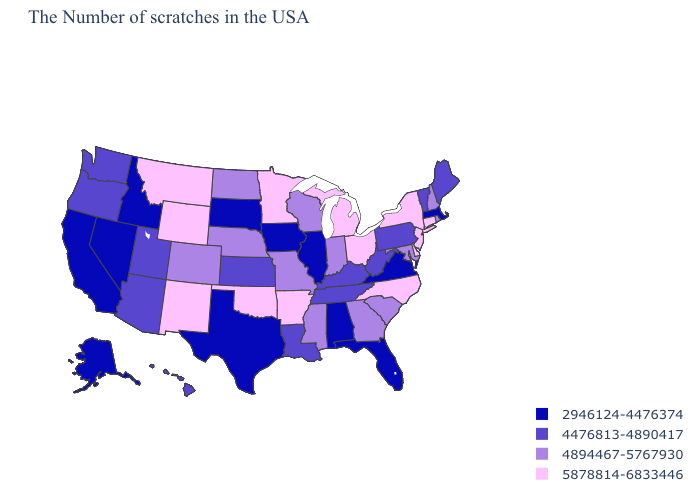Among the states that border Pennsylvania , which have the highest value?
Write a very short answer. New York, New Jersey, Delaware, Ohio. Does Hawaii have the same value as West Virginia?
Answer briefly. Yes. Which states have the lowest value in the USA?
Answer briefly. Massachusetts, Virginia, Florida, Alabama, Illinois, Iowa, Texas, South Dakota, Idaho, Nevada, California, Alaska. Does the map have missing data?
Keep it brief. No. What is the value of Michigan?
Write a very short answer. 5878814-6833446. Does Massachusetts have the highest value in the Northeast?
Answer briefly. No. What is the lowest value in states that border Mississippi?
Short answer required. 2946124-4476374. Does the map have missing data?
Concise answer only. No. Does Florida have the highest value in the USA?
Short answer required. No. Name the states that have a value in the range 5878814-6833446?
Short answer required. Connecticut, New York, New Jersey, Delaware, North Carolina, Ohio, Michigan, Arkansas, Minnesota, Oklahoma, Wyoming, New Mexico, Montana. What is the lowest value in states that border Virginia?
Write a very short answer. 4476813-4890417. Which states hav the highest value in the West?
Concise answer only. Wyoming, New Mexico, Montana. What is the highest value in states that border Arkansas?
Short answer required. 5878814-6833446. What is the value of Vermont?
Give a very brief answer. 4476813-4890417. Which states have the lowest value in the USA?
Write a very short answer. Massachusetts, Virginia, Florida, Alabama, Illinois, Iowa, Texas, South Dakota, Idaho, Nevada, California, Alaska. 